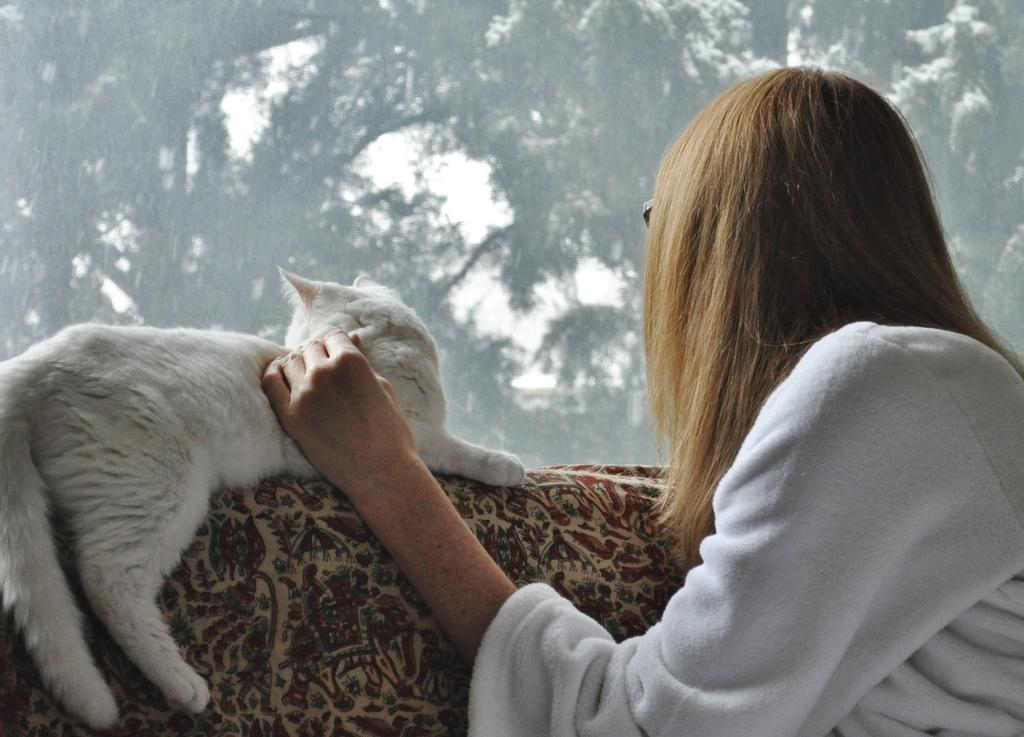Who is present in the image? There is a woman in the image. What is the woman doing in the image? The woman is sitting on a sofa. What is the woman doing with her hand in the image? The woman has her hand on a cat. Where is the cat located in relation to the woman? The cat is sitting beside the woman. What can be seen in the background of the image? There are trees in the background of the image. What is the limit of the woman's ability to look at the feeling in the image? There is no mention of a limit, looking, or feeling in the image; it simply shows a woman sitting on a sofa with a cat beside her and trees in the background. 